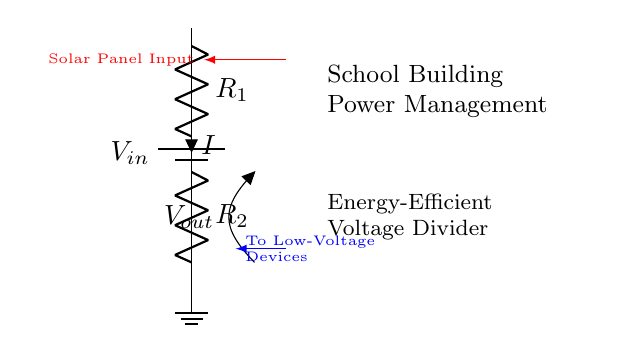What is the input voltage in this circuit? The input voltage, denoted as V_in, is represented by the battery symbol in the circuit diagram. It is the voltage supplied to the voltage divider.
Answer: V_in What do R_1 and R_2 represent? R_1 and R_2 are the resistances placed in series in the voltage divider configuration. They determine the division of the input voltage and affect the output voltage.
Answer: Resistors What is represented by V_out in the circuit? V_out is the output voltage taken across resistor R_2. It is the voltage that will be supplied to low-voltage devices connected to this point.
Answer: Output voltage How does the voltage divider work to support energy efficiency? The voltage divider reduces the input voltage to a lower level suitable for low-voltage devices, thus preventing energy loss from using higher voltage levels than necessary.
Answer: By reducing voltage What happens to the current when R_1 increases? Increasing R_1 will decrease the overall current in the circuit due to Ohm's Law, which results in less current flowing through both R_1 and R_2, affecting the output voltage.
Answer: Current decreases What is the relationship between R_1, R_2, and V_out? The output voltage V_out is determined by the ratio of R_2 to the total resistance (R_1 + R_2). This ratio affects how much of the input voltage is dropped across R_2, thus influencing V_out.
Answer: Voltage division ratio 